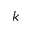Convert formula to latex. <formula><loc_0><loc_0><loc_500><loc_500>k</formula> 